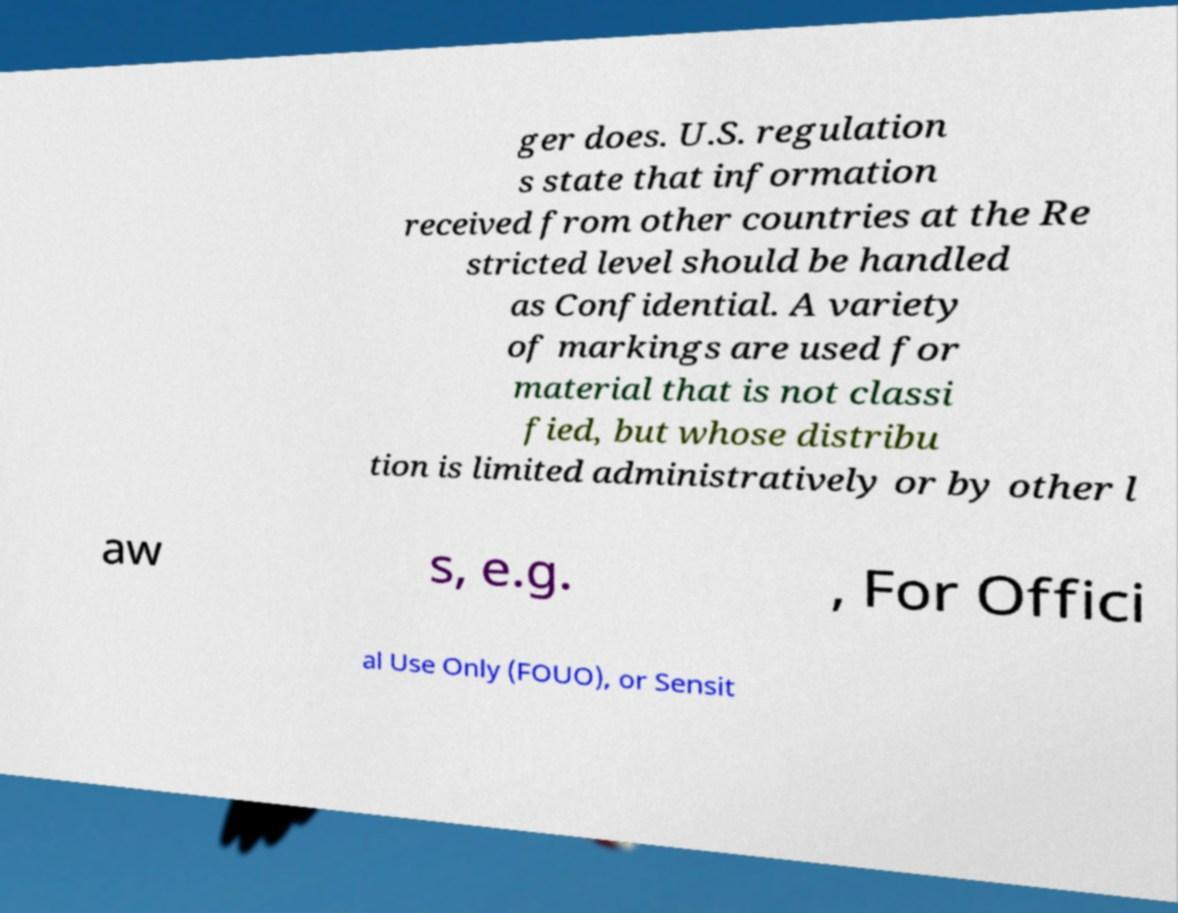Could you extract and type out the text from this image? ger does. U.S. regulation s state that information received from other countries at the Re stricted level should be handled as Confidential. A variety of markings are used for material that is not classi fied, but whose distribu tion is limited administratively or by other l aw s, e.g. , For Offici al Use Only (FOUO), or Sensit 